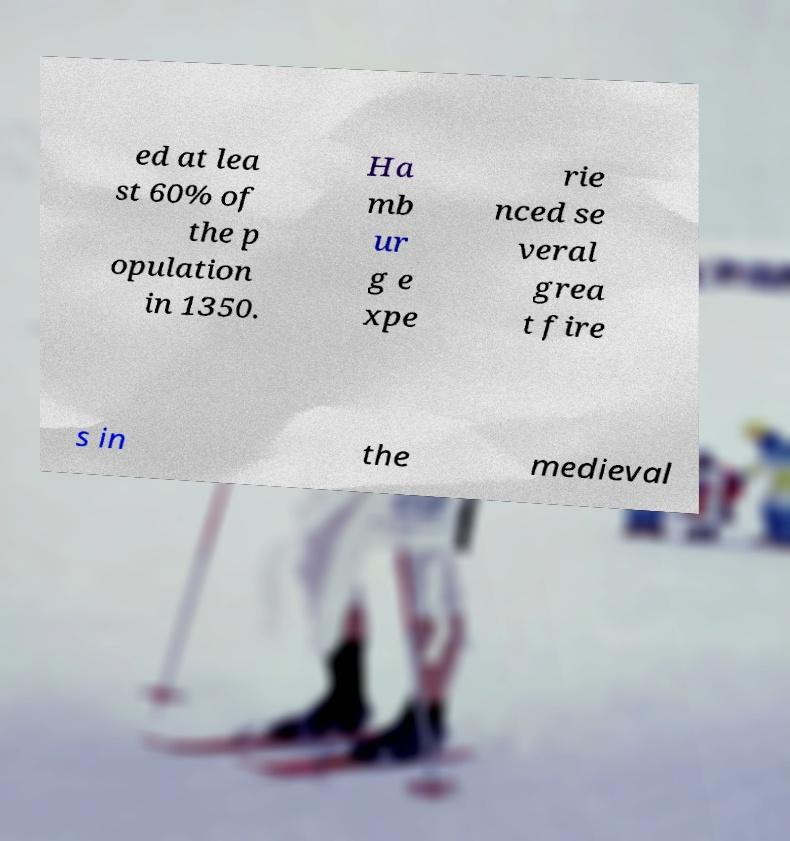Can you read and provide the text displayed in the image?This photo seems to have some interesting text. Can you extract and type it out for me? ed at lea st 60% of the p opulation in 1350. Ha mb ur g e xpe rie nced se veral grea t fire s in the medieval 